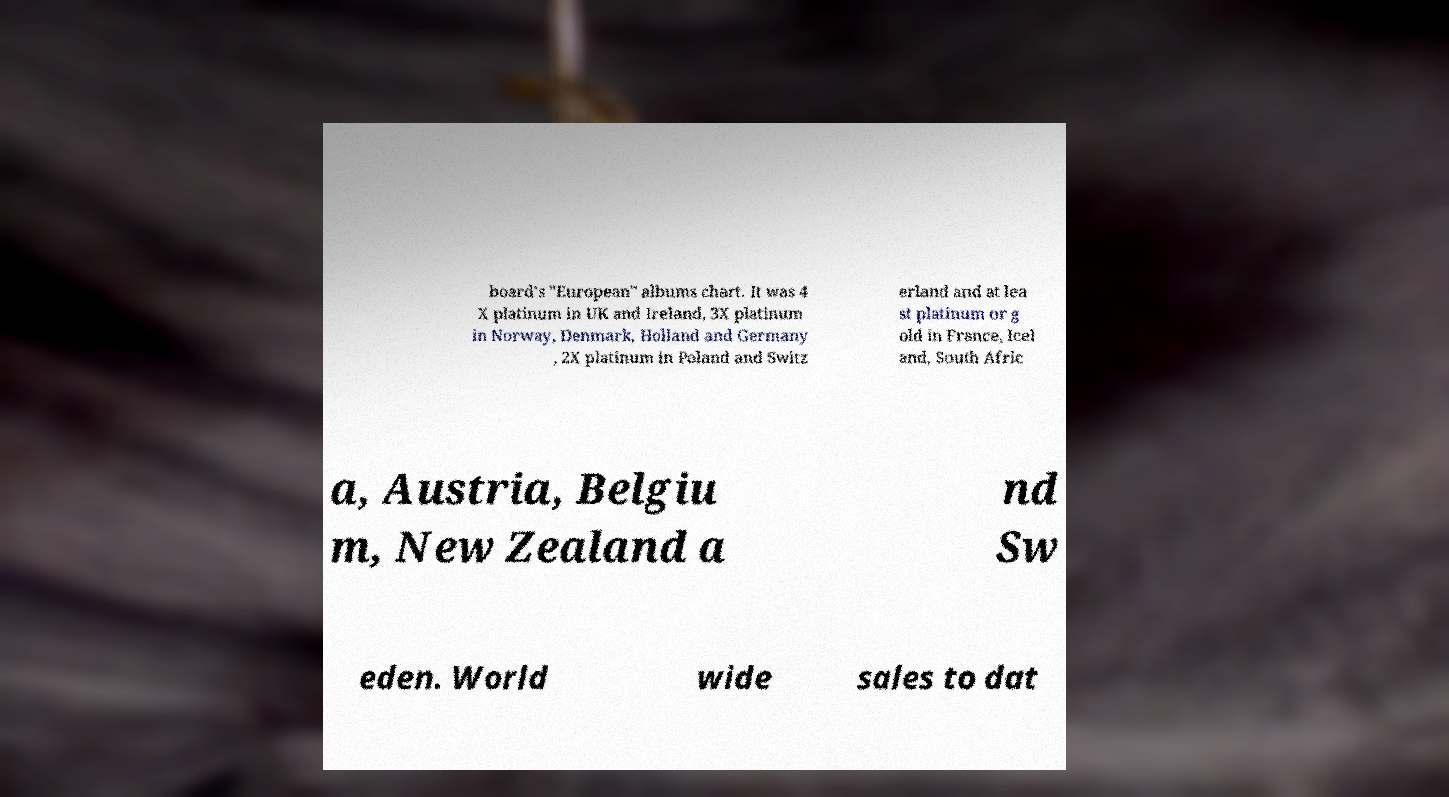Please read and relay the text visible in this image. What does it say? board's "European" albums chart. It was 4 X platinum in UK and Ireland, 3X platinum in Norway, Denmark, Holland and Germany , 2X platinum in Poland and Switz erland and at lea st platinum or g old in France, Icel and, South Afric a, Austria, Belgiu m, New Zealand a nd Sw eden. World wide sales to dat 